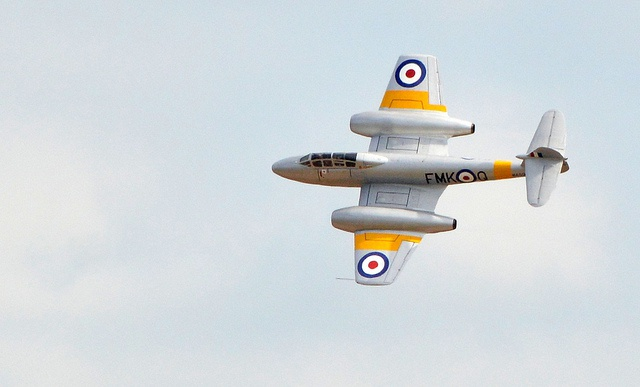Describe the objects in this image and their specific colors. I can see a airplane in lightgray, darkgray, gray, and orange tones in this image. 